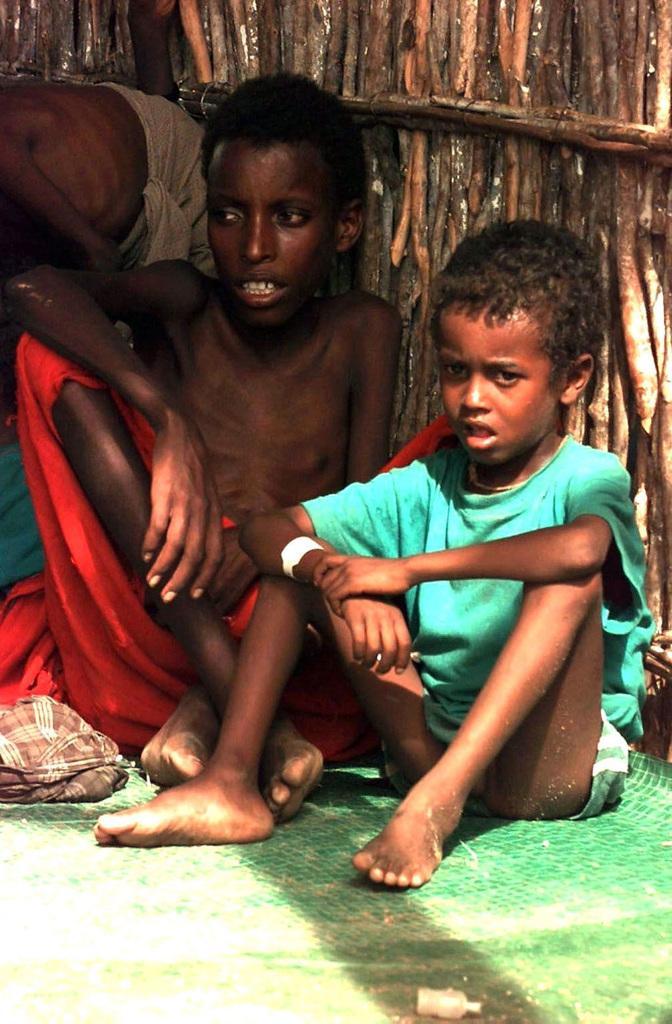Please provide a concise description of this image. In this image there are some people who are sitting, and at the bottom there is mat and clothes. In the background there are some wooden poles. 